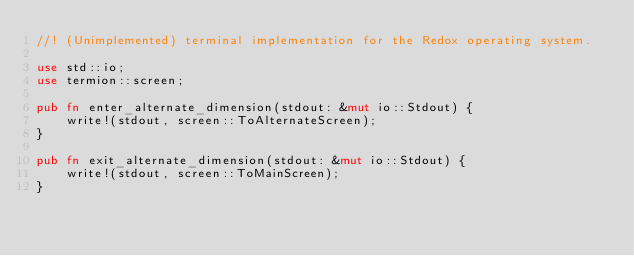Convert code to text. <code><loc_0><loc_0><loc_500><loc_500><_Rust_>//! (Unimplemented) terminal implementation for the Redox operating system.

use std::io;
use termion::screen;

pub fn enter_alternate_dimension(stdout: &mut io::Stdout) {
    write!(stdout, screen::ToAlternateScreen);
}

pub fn exit_alternate_dimension(stdout: &mut io::Stdout) {
    write!(stdout, screen::ToMainScreen);
}
</code> 